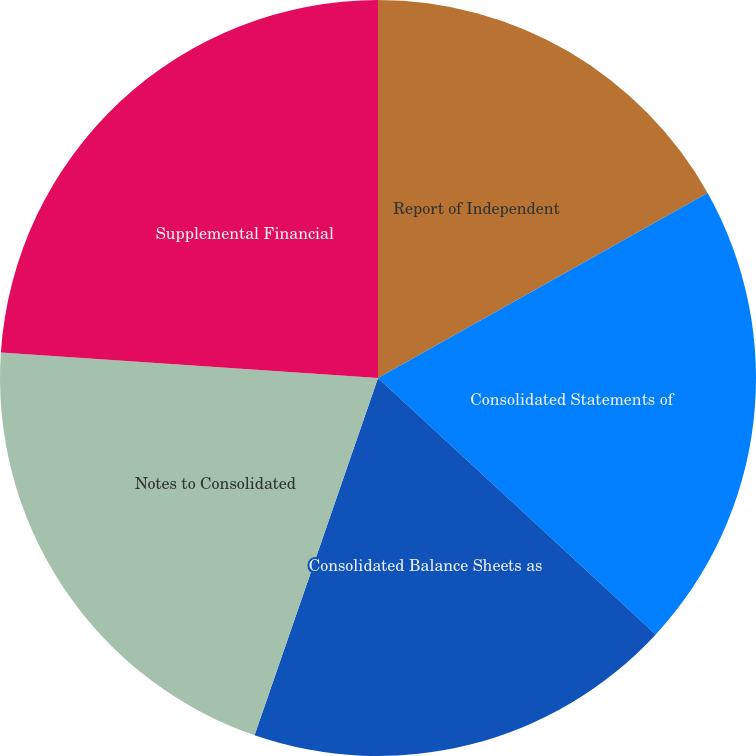<chart> <loc_0><loc_0><loc_500><loc_500><pie_chart><fcel>Report of Independent<fcel>Consolidated Statements of<fcel>Consolidated Balance Sheets as<fcel>Notes to Consolidated<fcel>Supplemental Financial<nl><fcel>16.86%<fcel>20.0%<fcel>18.43%<fcel>20.78%<fcel>23.92%<nl></chart> 